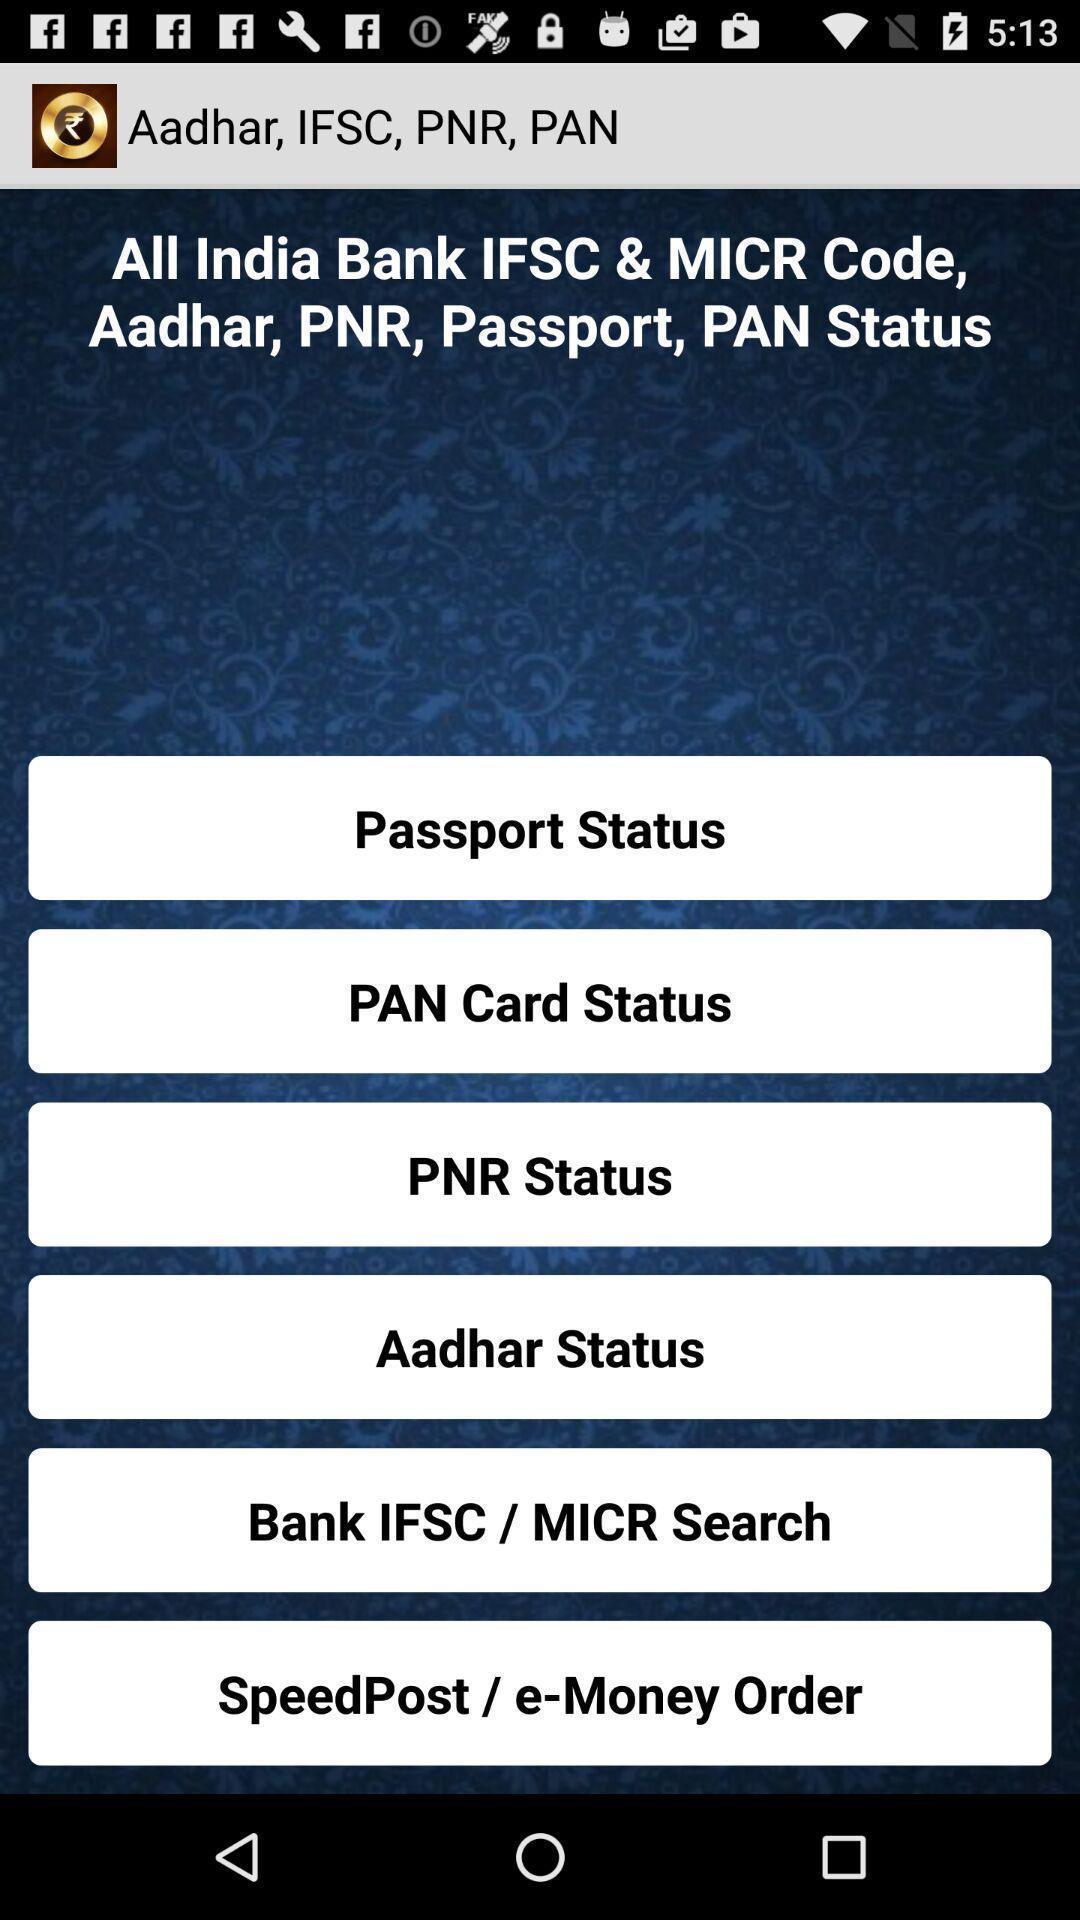Describe the content in this image. Screen displaying list of options to know the status. 